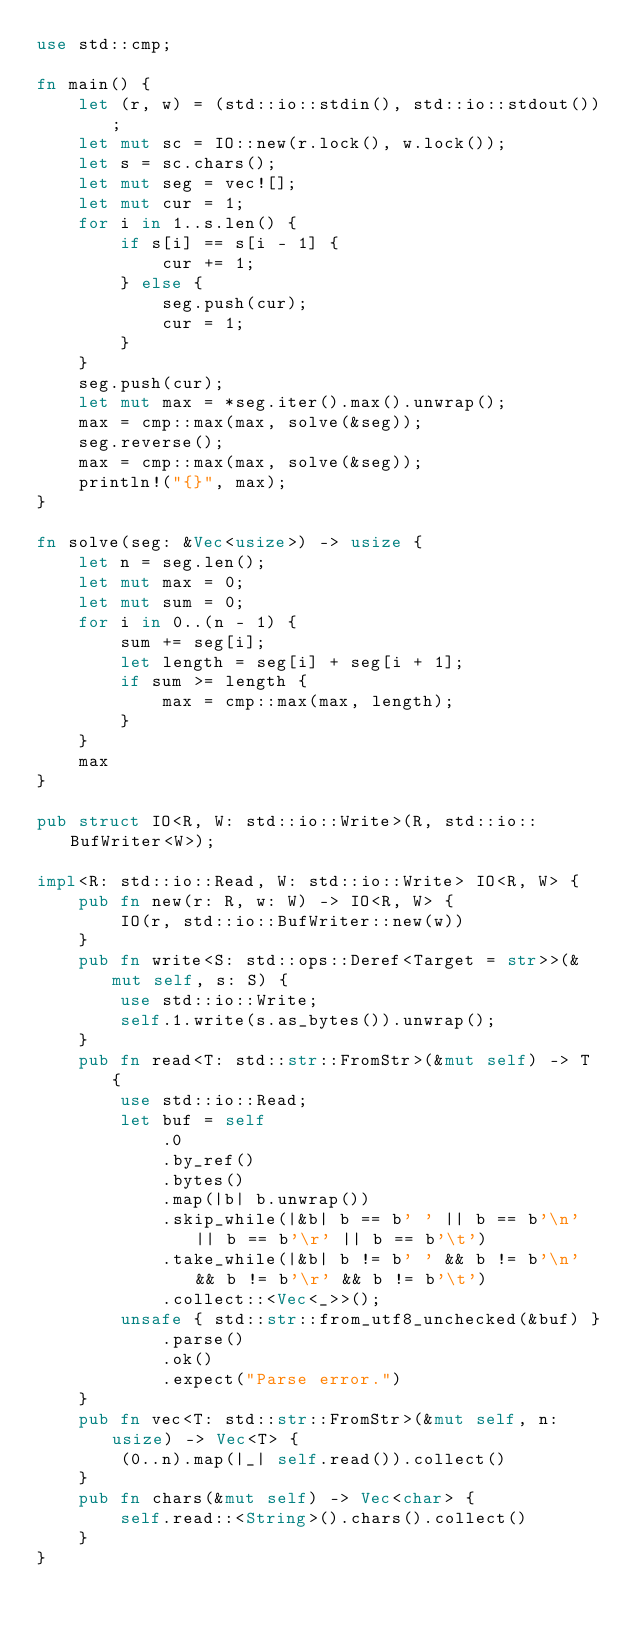Convert code to text. <code><loc_0><loc_0><loc_500><loc_500><_Rust_>use std::cmp;

fn main() {
    let (r, w) = (std::io::stdin(), std::io::stdout());
    let mut sc = IO::new(r.lock(), w.lock());
    let s = sc.chars();
    let mut seg = vec![];
    let mut cur = 1;
    for i in 1..s.len() {
        if s[i] == s[i - 1] {
            cur += 1;
        } else {
            seg.push(cur);
            cur = 1;
        }
    }
    seg.push(cur);
    let mut max = *seg.iter().max().unwrap();
    max = cmp::max(max, solve(&seg));
    seg.reverse();
    max = cmp::max(max, solve(&seg));
    println!("{}", max);
}

fn solve(seg: &Vec<usize>) -> usize {
    let n = seg.len();
    let mut max = 0;
    let mut sum = 0;
    for i in 0..(n - 1) {
        sum += seg[i];
        let length = seg[i] + seg[i + 1];
        if sum >= length {
            max = cmp::max(max, length);
        }
    }
    max
}

pub struct IO<R, W: std::io::Write>(R, std::io::BufWriter<W>);

impl<R: std::io::Read, W: std::io::Write> IO<R, W> {
    pub fn new(r: R, w: W) -> IO<R, W> {
        IO(r, std::io::BufWriter::new(w))
    }
    pub fn write<S: std::ops::Deref<Target = str>>(&mut self, s: S) {
        use std::io::Write;
        self.1.write(s.as_bytes()).unwrap();
    }
    pub fn read<T: std::str::FromStr>(&mut self) -> T {
        use std::io::Read;
        let buf = self
            .0
            .by_ref()
            .bytes()
            .map(|b| b.unwrap())
            .skip_while(|&b| b == b' ' || b == b'\n' || b == b'\r' || b == b'\t')
            .take_while(|&b| b != b' ' && b != b'\n' && b != b'\r' && b != b'\t')
            .collect::<Vec<_>>();
        unsafe { std::str::from_utf8_unchecked(&buf) }
            .parse()
            .ok()
            .expect("Parse error.")
    }
    pub fn vec<T: std::str::FromStr>(&mut self, n: usize) -> Vec<T> {
        (0..n).map(|_| self.read()).collect()
    }
    pub fn chars(&mut self) -> Vec<char> {
        self.read::<String>().chars().collect()
    }
}
</code> 